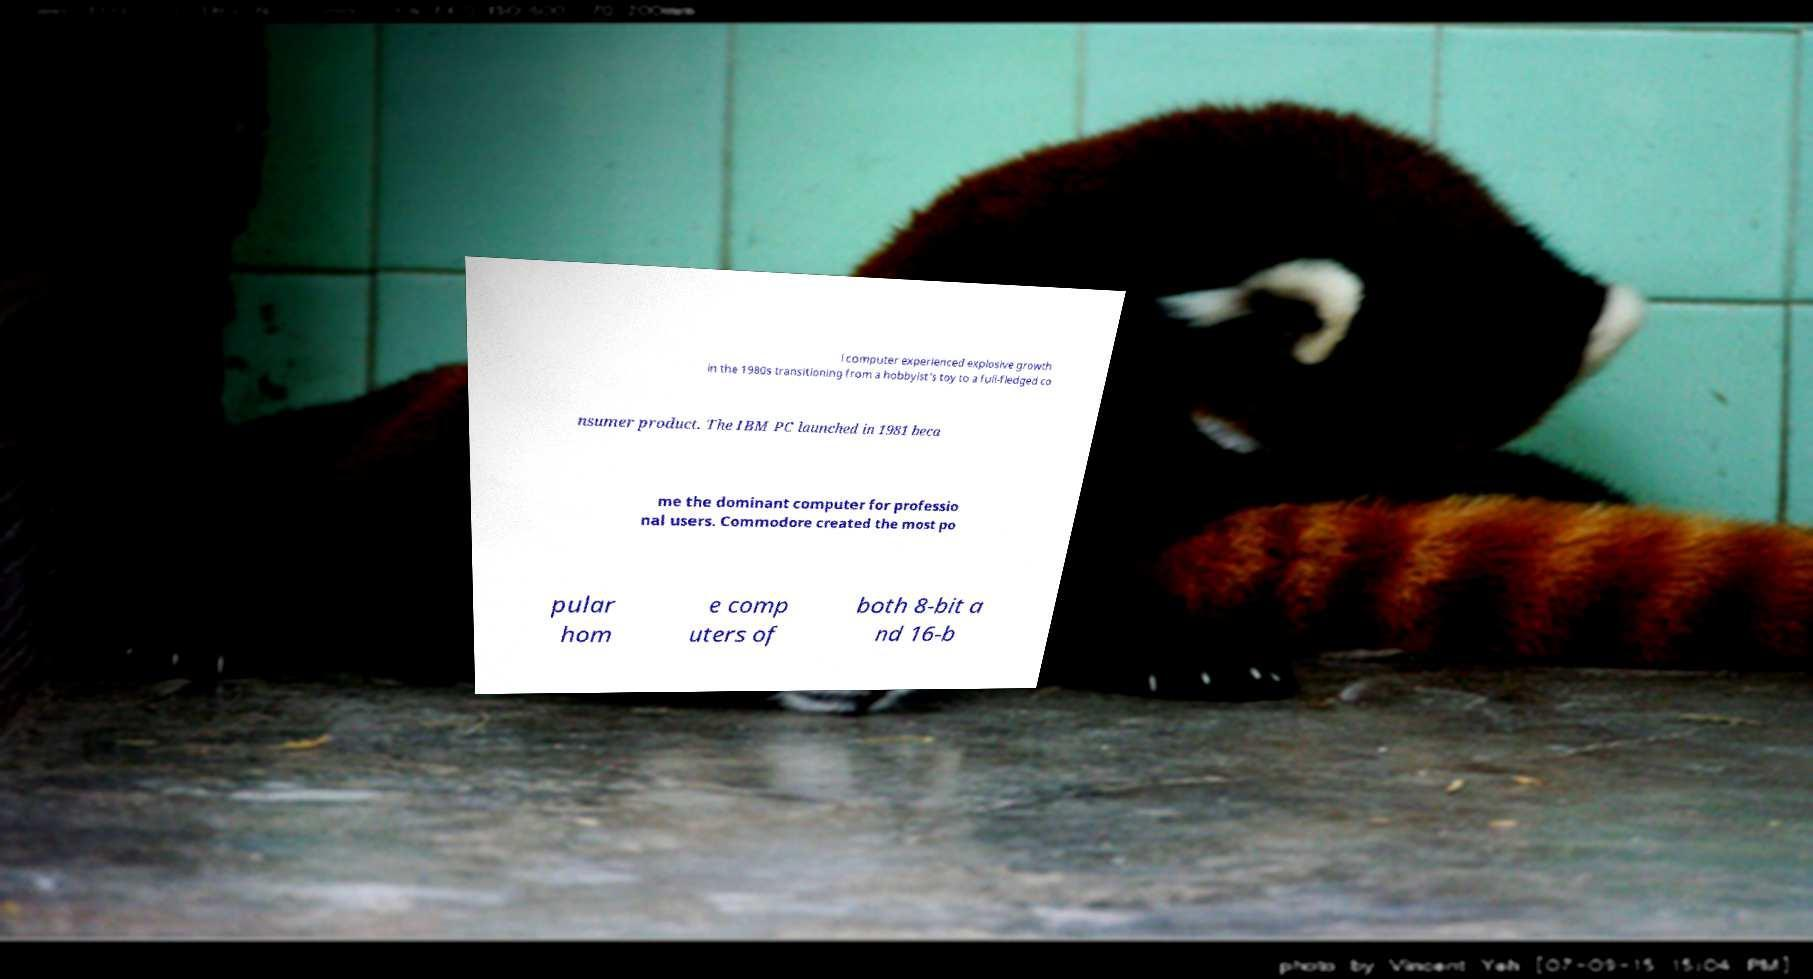Could you assist in decoding the text presented in this image and type it out clearly? l computer experienced explosive growth in the 1980s transitioning from a hobbyist's toy to a full-fledged co nsumer product. The IBM PC launched in 1981 beca me the dominant computer for professio nal users. Commodore created the most po pular hom e comp uters of both 8-bit a nd 16-b 